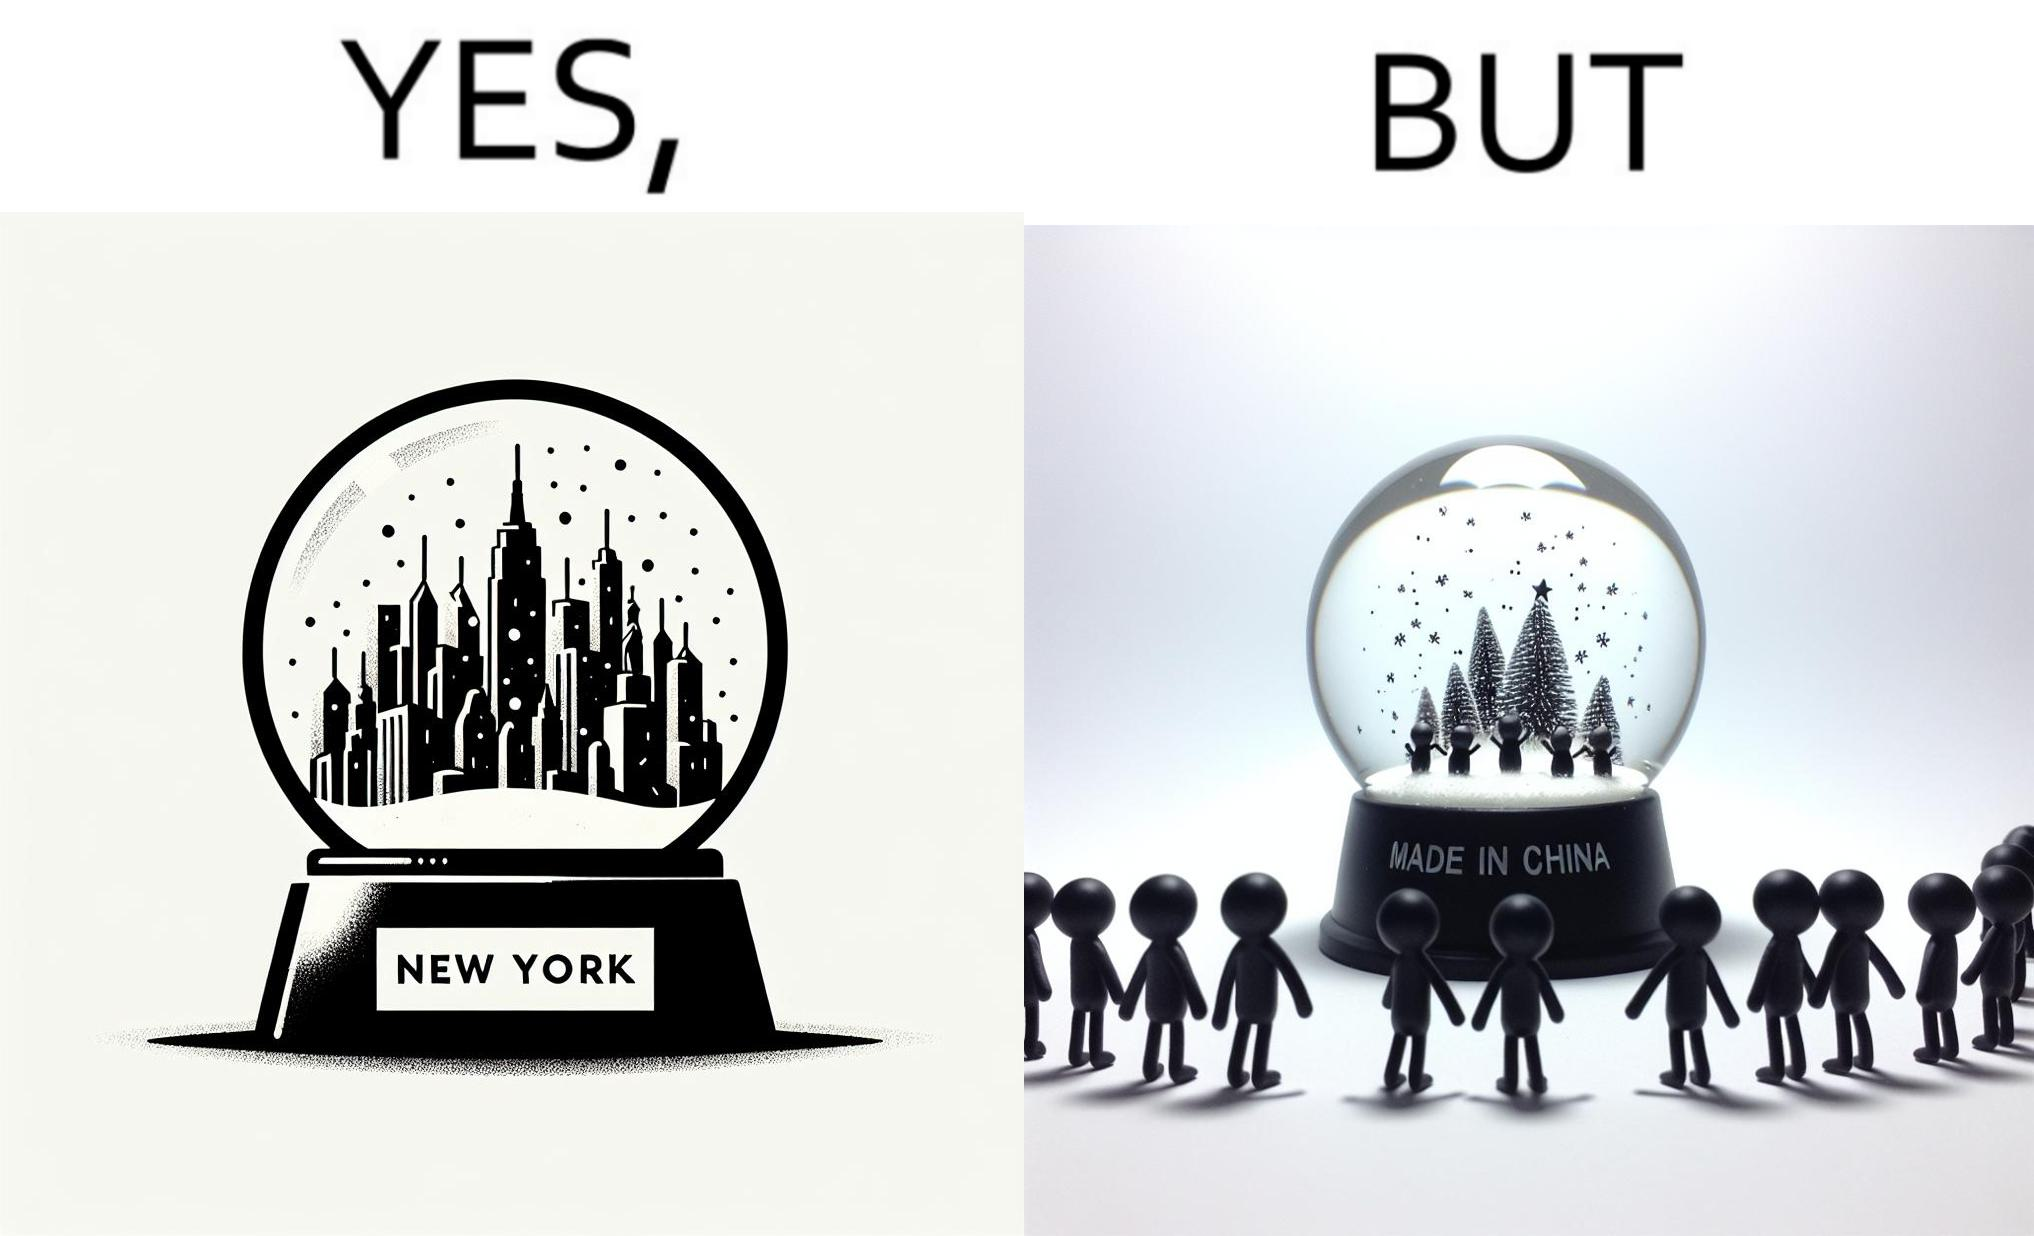Provide a description of this image. The image is ironic because the snowglobe says 'New York' while it is made in China 